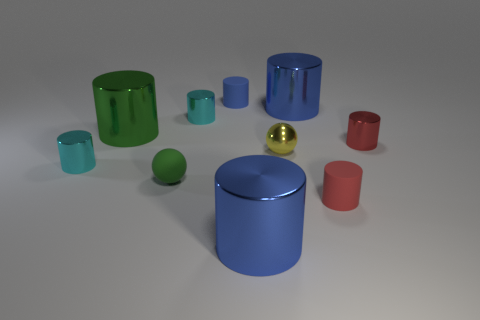The blue object that is made of the same material as the small green thing is what size?
Offer a very short reply. Small. How many other yellow things are the same shape as the yellow metal object?
Your response must be concise. 0. Are there more large things that are in front of the red rubber cylinder than tiny yellow spheres that are behind the small yellow metal object?
Provide a short and direct response. Yes. Do the tiny rubber ball and the big cylinder on the left side of the rubber sphere have the same color?
Make the answer very short. Yes. What is the material of the yellow sphere that is the same size as the red shiny cylinder?
Provide a short and direct response. Metal. What number of objects are either big metallic things or metallic things that are in front of the tiny yellow object?
Ensure brevity in your answer.  4. There is a metal sphere; does it have the same size as the blue cylinder that is in front of the big green cylinder?
Offer a terse response. No. What number of cylinders are small red shiny objects or cyan metallic objects?
Give a very brief answer. 3. How many small cylinders are right of the rubber sphere and in front of the yellow ball?
Keep it short and to the point. 1. How many other objects are the same color as the tiny matte ball?
Give a very brief answer. 1. 